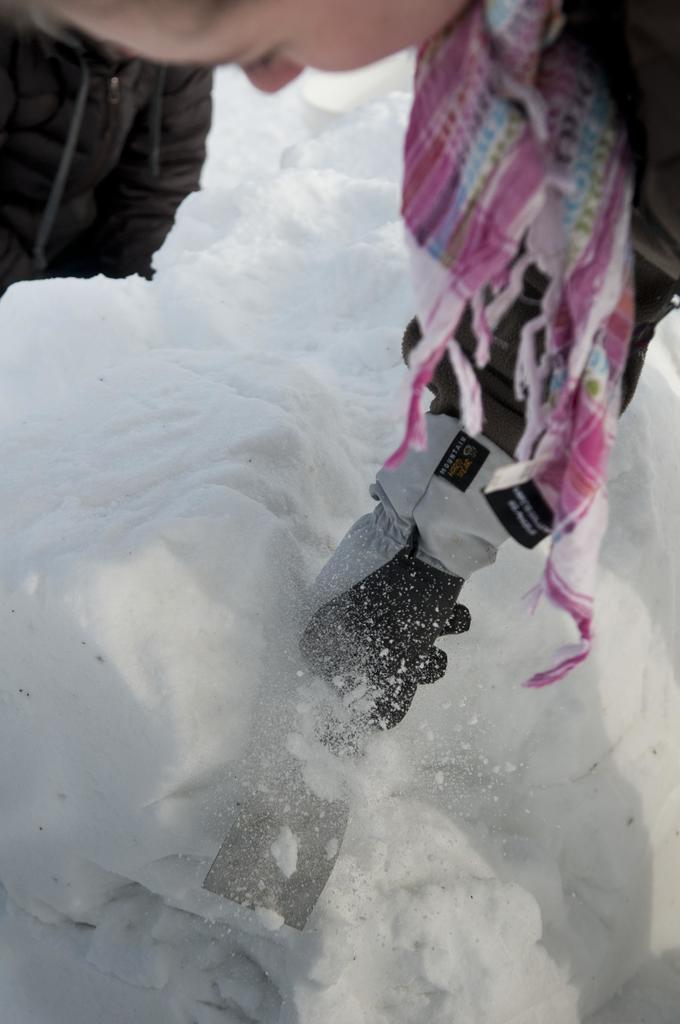Who is present in the image? There is a person in the image. What is the person standing on? The person is standing on an ice mountain. Can you describe the time of day when the image was taken? The image is likely taken during the day. What type of location is depicted in the image? The location is a mountain. How many cats are visible on the ice mountain in the image? There are no cats present in the image; it features a person standing on an ice mountain. What type of jellyfish can be seen swimming in the background of the image? There is no jellyfish present in the image, as it is set on an ice mountain. 